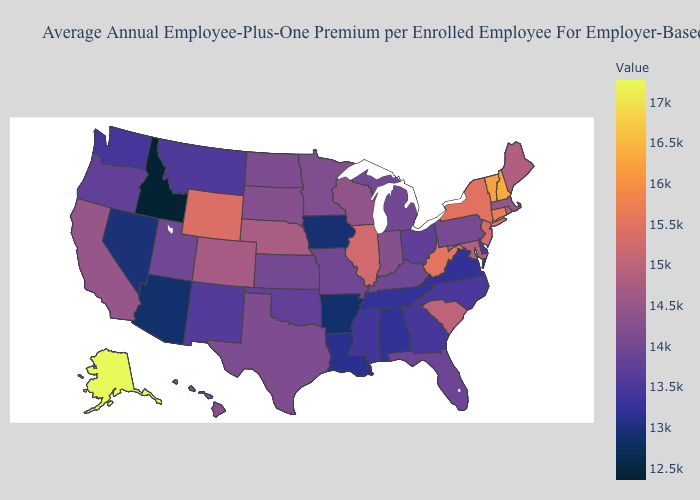Which states hav the highest value in the South?
Answer briefly. West Virginia. Which states have the highest value in the USA?
Be succinct. Alaska. Does New Mexico have the highest value in the USA?
Keep it brief. No. 